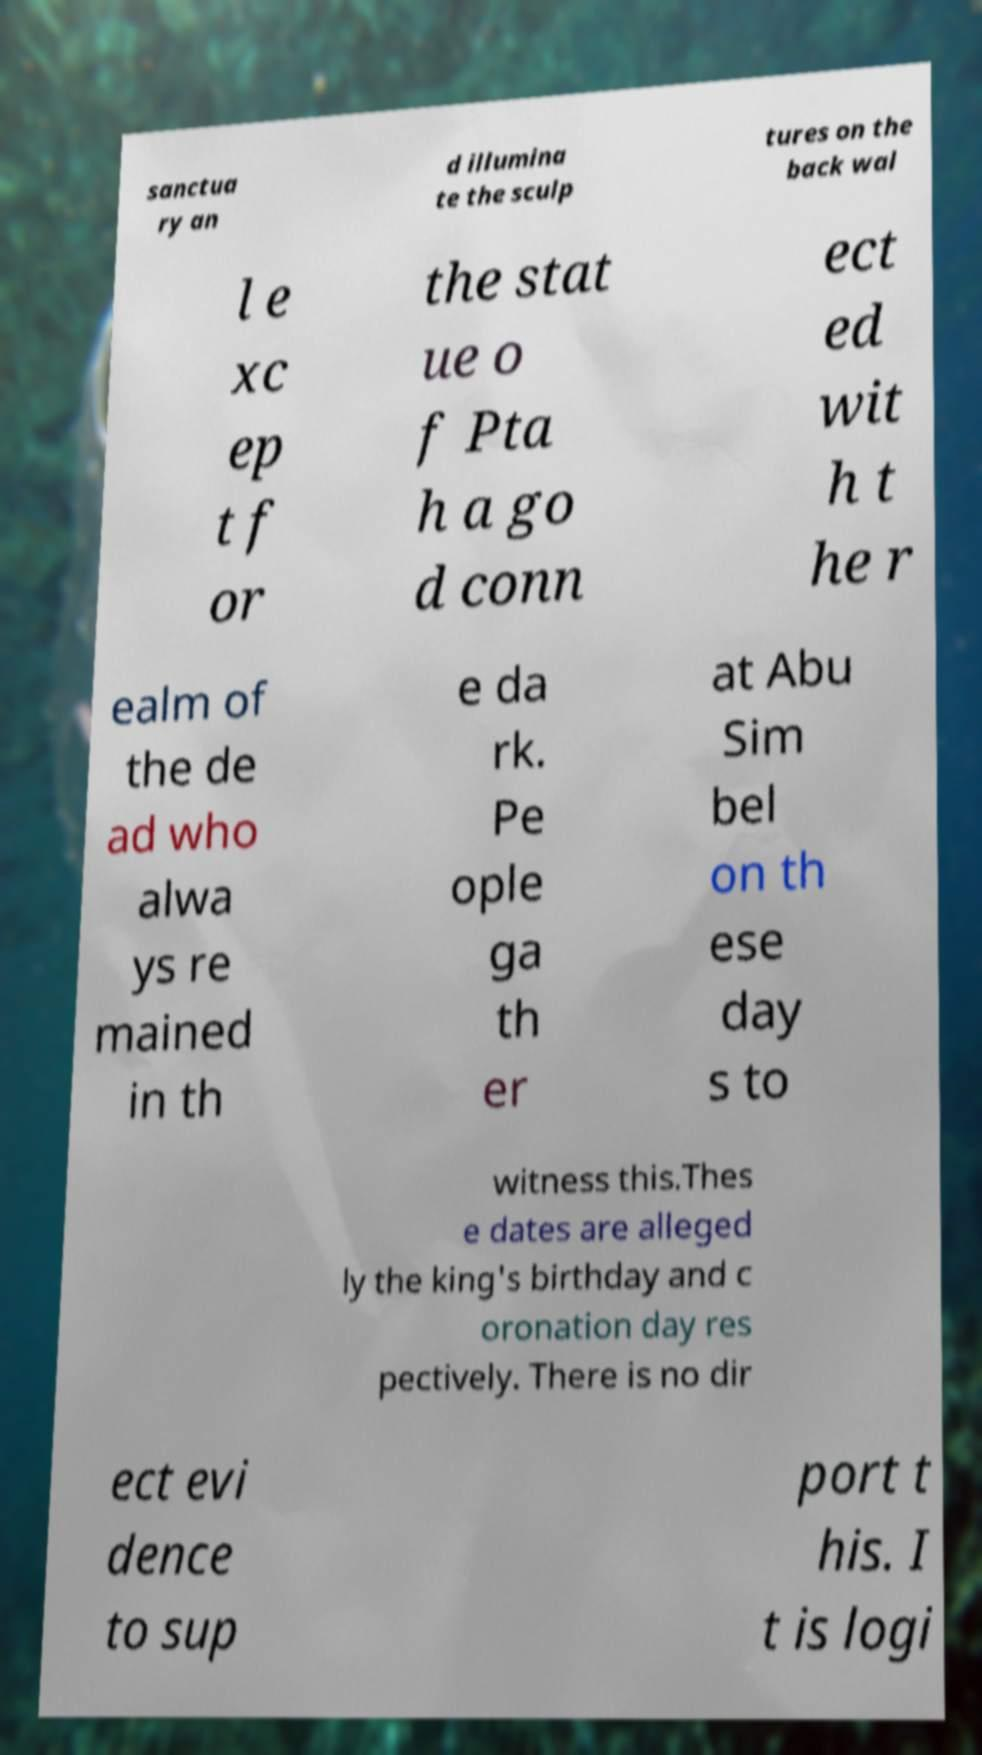What messages or text are displayed in this image? I need them in a readable, typed format. sanctua ry an d illumina te the sculp tures on the back wal l e xc ep t f or the stat ue o f Pta h a go d conn ect ed wit h t he r ealm of the de ad who alwa ys re mained in th e da rk. Pe ople ga th er at Abu Sim bel on th ese day s to witness this.Thes e dates are alleged ly the king's birthday and c oronation day res pectively. There is no dir ect evi dence to sup port t his. I t is logi 